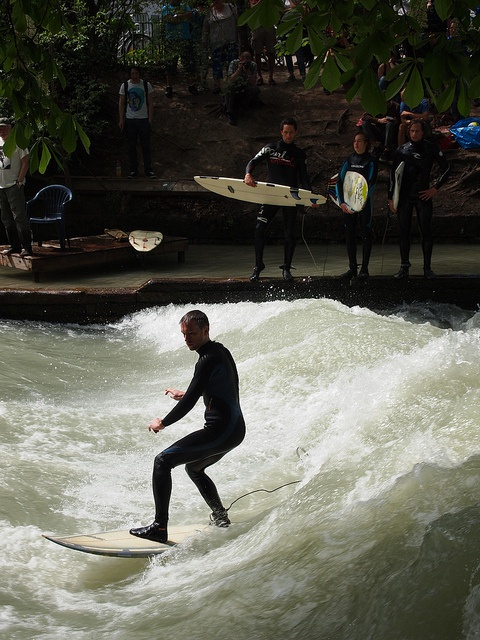Describe the objects in this image and their specific colors. I can see people in black, lightgray, gray, and darkgray tones, people in black, maroon, and gray tones, people in black, gray, and maroon tones, people in black, darkgray, and gray tones, and people in black, gray, and purple tones in this image. 